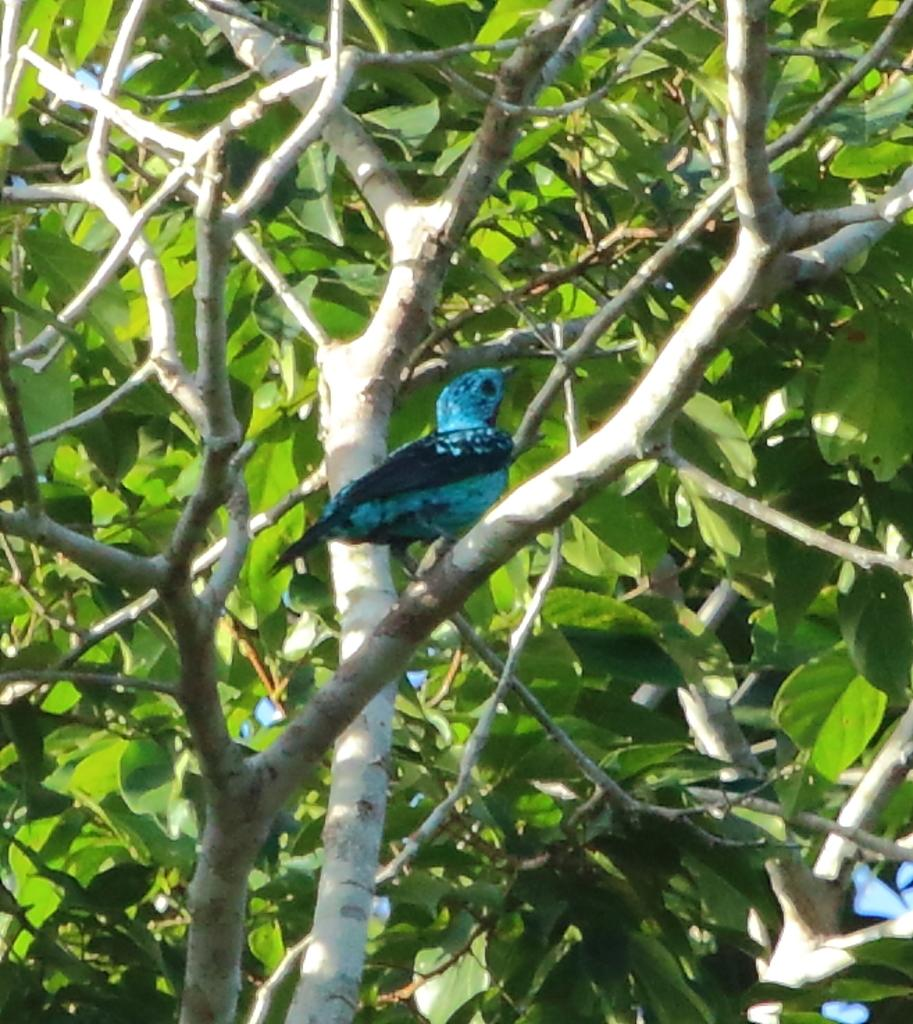What is present in the image that is a part of nature? There is a tree in the image. Can you describe the bird that is visible in the image? There is a bird on the branch of the tree, and it is blue in color. What is covering the branches of the tree? There are leaves on the tree. What type of lace can be seen hanging from the branches of the tree in the image? There is no lace present in the image; it is a tree with a bird and leaves. Can you tell me how many cows are grazing on the farm in the image? There is no farm or cows present in the image; it features a tree with a bird and leaves. 